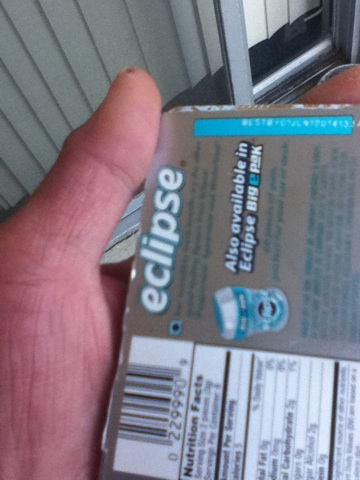Can you tell me more about the ingredients in this gum? I'm sorry, but the ingredients list is not clearly visible in the image provided. Normally, Eclipse gum ingredients might include sweeteners, gum base, flavorings, and softeners. 